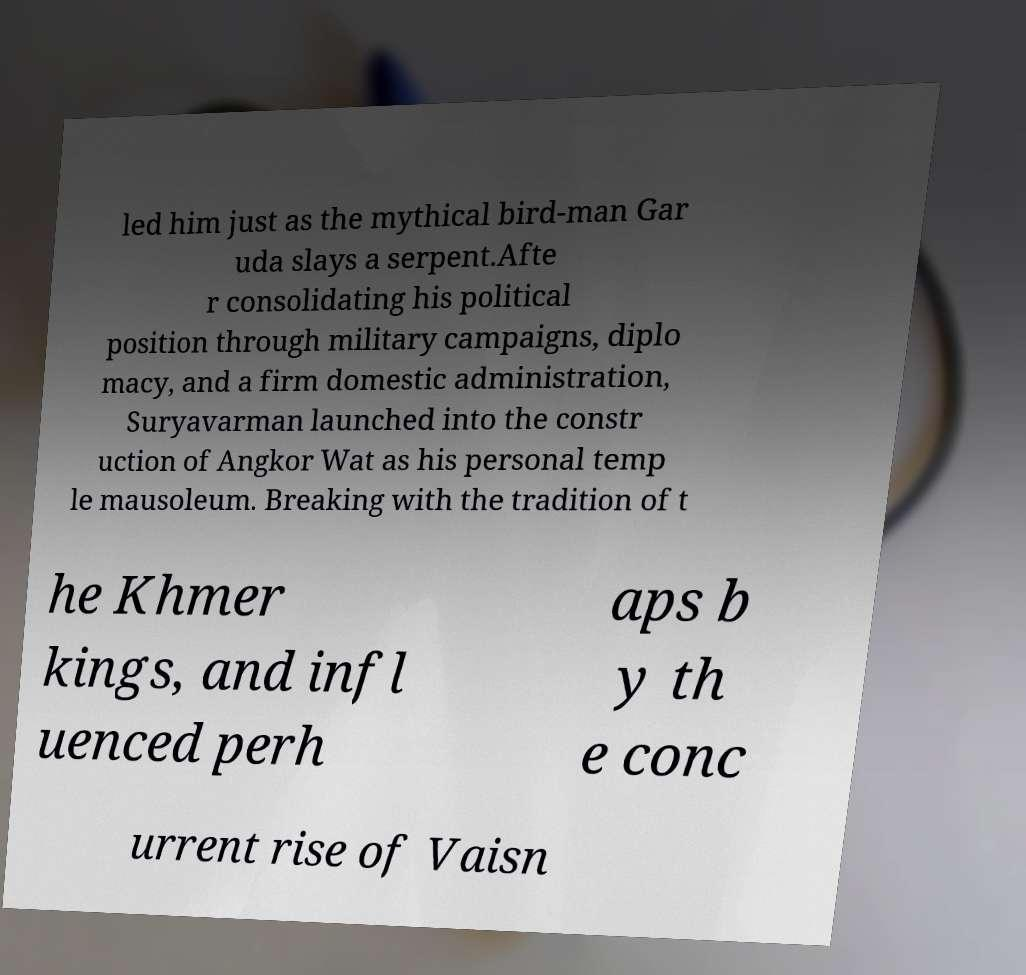Can you read and provide the text displayed in the image?This photo seems to have some interesting text. Can you extract and type it out for me? led him just as the mythical bird-man Gar uda slays a serpent.Afte r consolidating his political position through military campaigns, diplo macy, and a firm domestic administration, Suryavarman launched into the constr uction of Angkor Wat as his personal temp le mausoleum. Breaking with the tradition of t he Khmer kings, and infl uenced perh aps b y th e conc urrent rise of Vaisn 